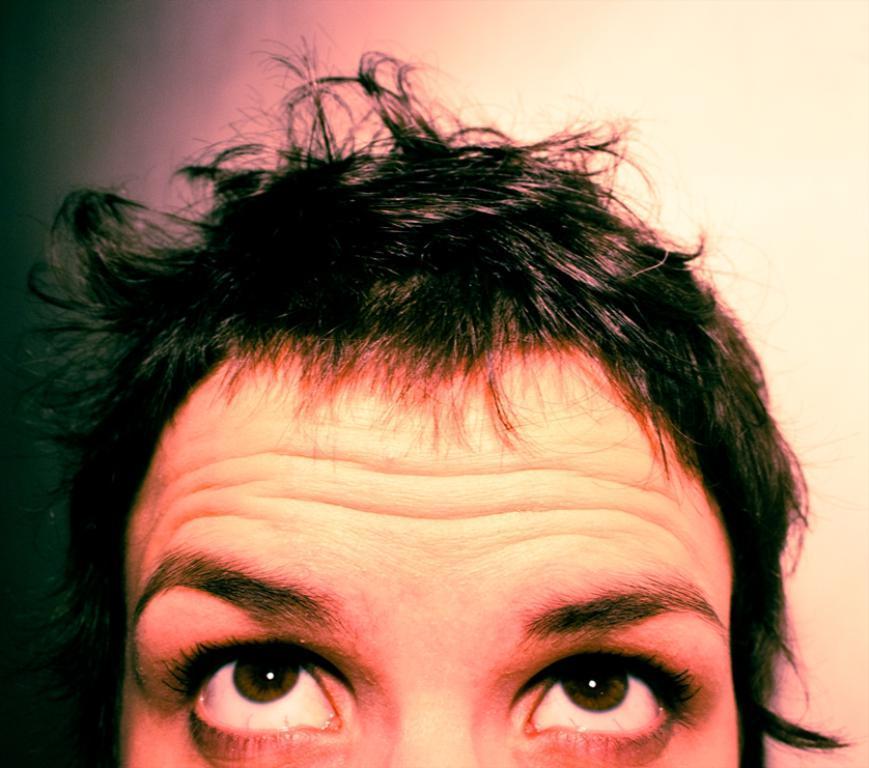Describe this image in one or two sentences. In this image we can see a person and a wall in the background. 